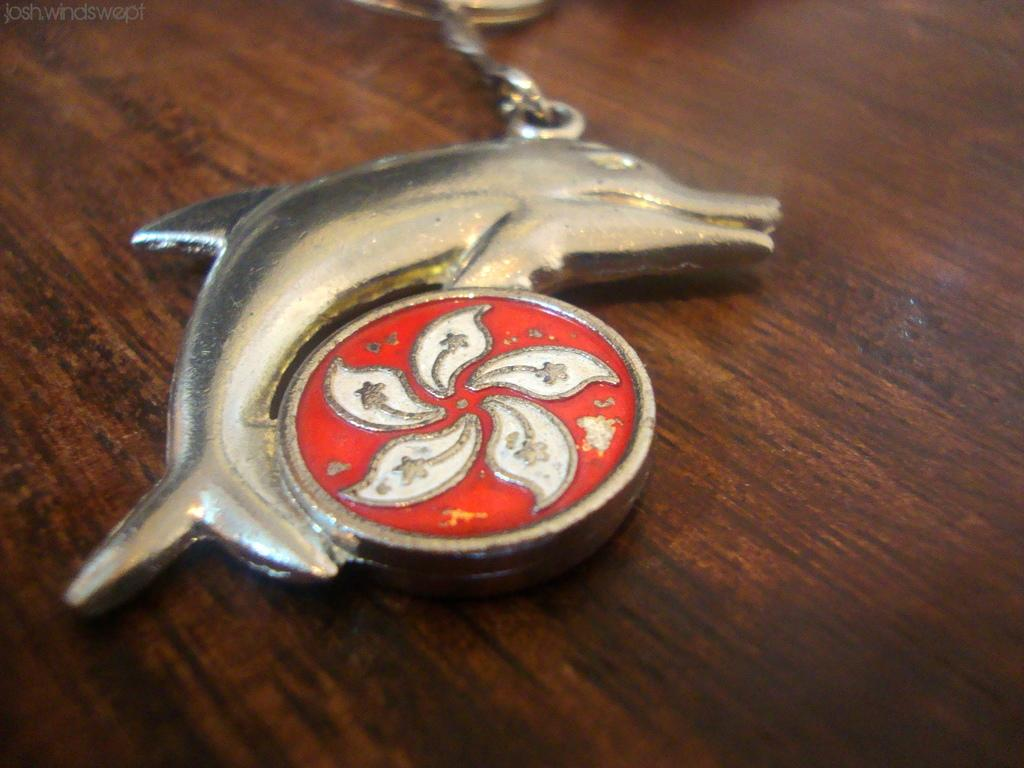What is the shape of the object in the image? The object in the image is shaped like a dolphin. What is the color of the object in the image? The object in the image is silver-colored. What type of surface is the object resting on? The object is on a wooden surface. What story does the dolphin-shaped object tell in the image? The image does not convey a story, and the dolphin-shaped object is not telling a story. 